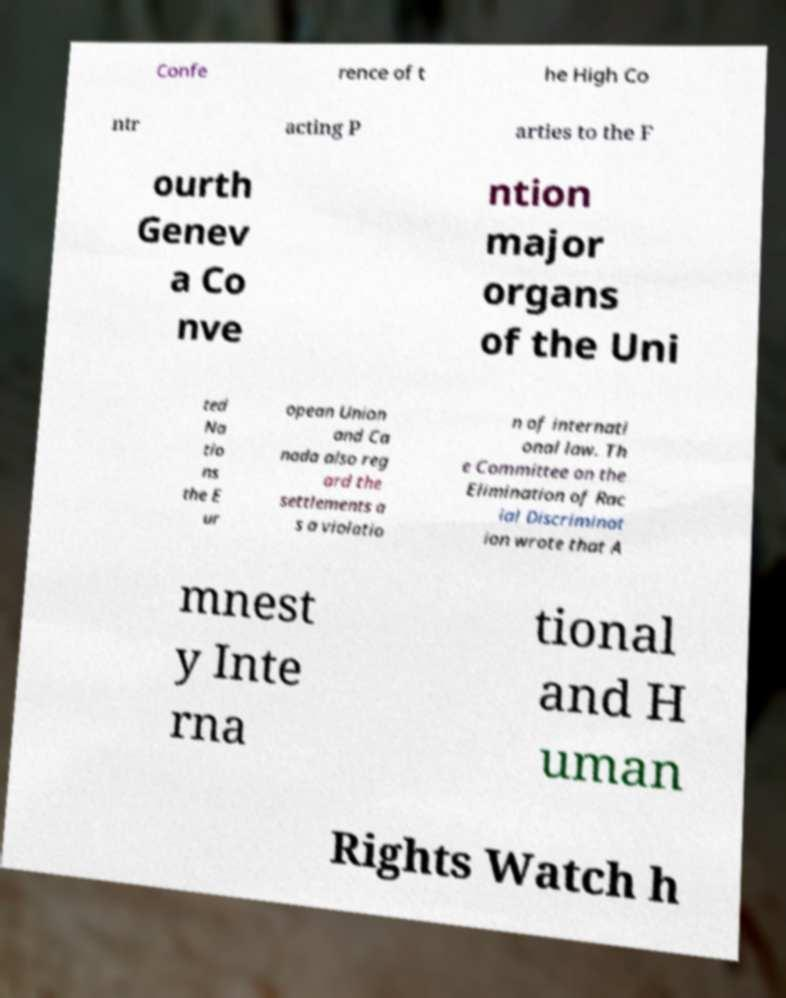Please identify and transcribe the text found in this image. Confe rence of t he High Co ntr acting P arties to the F ourth Genev a Co nve ntion major organs of the Uni ted Na tio ns the E ur opean Union and Ca nada also reg ard the settlements a s a violatio n of internati onal law. Th e Committee on the Elimination of Rac ial Discriminat ion wrote that A mnest y Inte rna tional and H uman Rights Watch h 